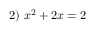<formula> <loc_0><loc_0><loc_500><loc_500>2 ) \ x ^ { 2 } + 2 x = 2</formula> 